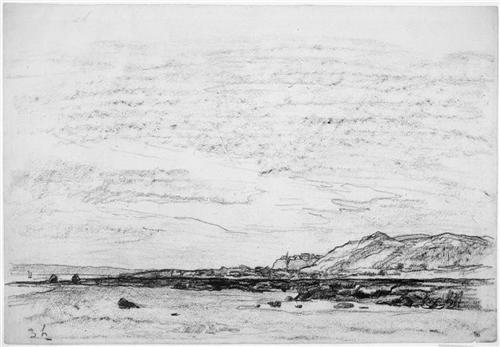What is this photo about'? The image is a black and white sketch that captures a serene landscape. The art style is impressionistic, characterized by its loose, sketchy style with a lot of texture and line work. The composition is horizontal, with the horizon line placed in the upper third of the image, following the rule of thirds. 

The foreground of the image features a rocky shore, dotted with a few scattered boulders. These elements add depth to the scene and draw the viewer's eye into the image. 

In the background, a majestic mountain range stretches across the scene, its peaks reaching up towards a sky scattered with a few clouds. The mountains and the sky take up the majority of the image, creating a sense of vastness and grandeur. 

Despite the absence of color, the artist has skillfully used varying shades of black and white to create contrast and depth, bringing the landscape to life. The overall effect is a tranquil and timeless scene that invites the viewer to pause and take in the beauty of nature. 